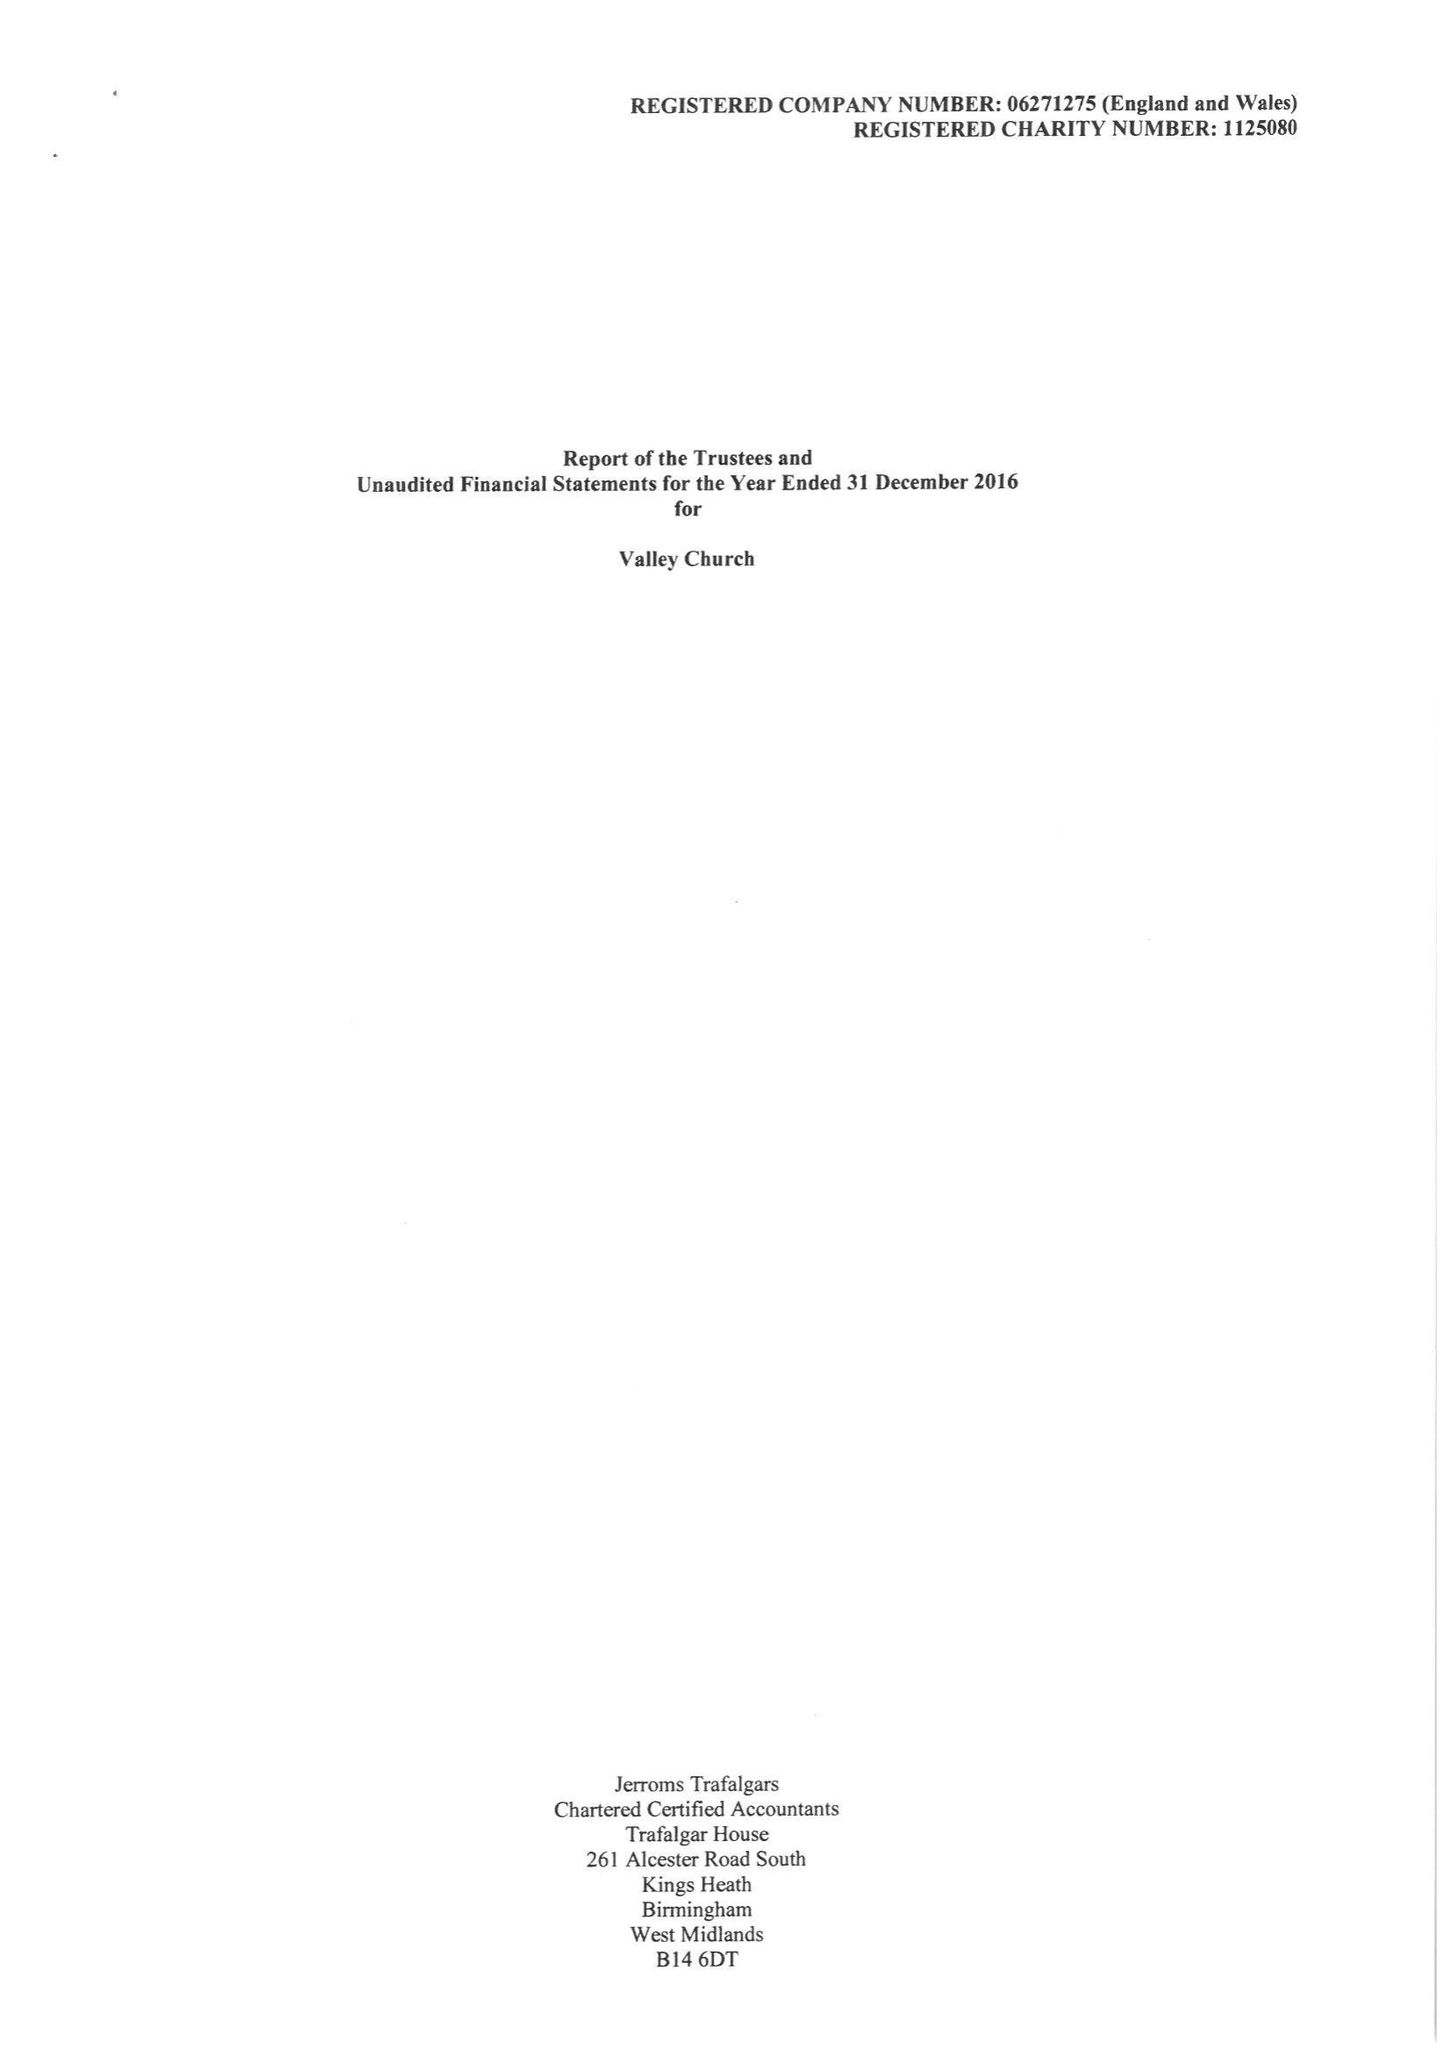What is the value for the address__street_line?
Answer the question using a single word or phrase. 2 KENSINGTON GARDENS 